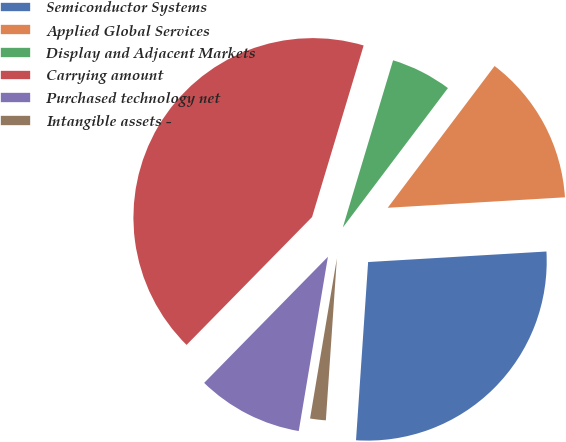<chart> <loc_0><loc_0><loc_500><loc_500><pie_chart><fcel>Semiconductor Systems<fcel>Applied Global Services<fcel>Display and Adjacent Markets<fcel>Carrying amount<fcel>Purchased technology net<fcel>Intangible assets -<nl><fcel>27.02%<fcel>13.78%<fcel>5.63%<fcel>42.3%<fcel>9.71%<fcel>1.56%<nl></chart> 